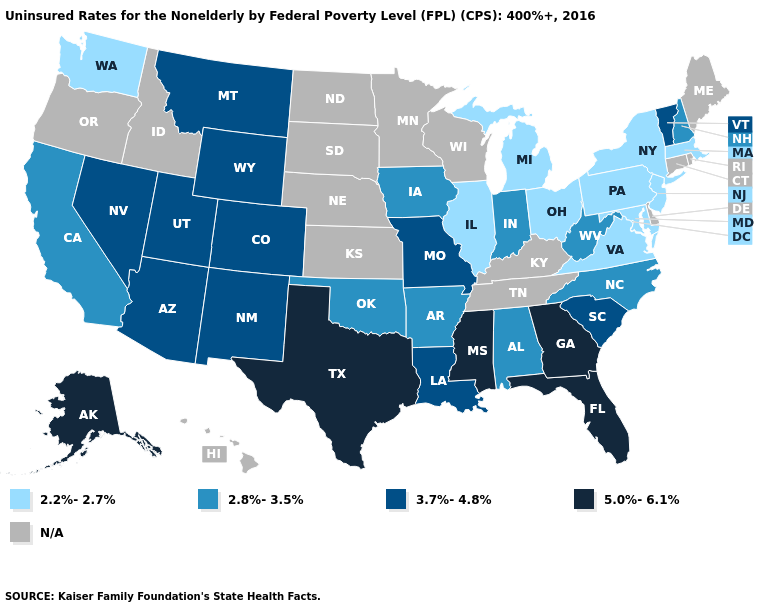Name the states that have a value in the range 3.7%-4.8%?
Concise answer only. Arizona, Colorado, Louisiana, Missouri, Montana, Nevada, New Mexico, South Carolina, Utah, Vermont, Wyoming. Name the states that have a value in the range 2.2%-2.7%?
Answer briefly. Illinois, Maryland, Massachusetts, Michigan, New Jersey, New York, Ohio, Pennsylvania, Virginia, Washington. What is the highest value in states that border Massachusetts?
Write a very short answer. 3.7%-4.8%. What is the value of Connecticut?
Quick response, please. N/A. Does California have the lowest value in the USA?
Give a very brief answer. No. Does Wyoming have the lowest value in the West?
Answer briefly. No. Which states have the highest value in the USA?
Give a very brief answer. Alaska, Florida, Georgia, Mississippi, Texas. Name the states that have a value in the range N/A?
Concise answer only. Connecticut, Delaware, Hawaii, Idaho, Kansas, Kentucky, Maine, Minnesota, Nebraska, North Dakota, Oregon, Rhode Island, South Dakota, Tennessee, Wisconsin. Is the legend a continuous bar?
Give a very brief answer. No. Name the states that have a value in the range 3.7%-4.8%?
Be succinct. Arizona, Colorado, Louisiana, Missouri, Montana, Nevada, New Mexico, South Carolina, Utah, Vermont, Wyoming. Name the states that have a value in the range 2.8%-3.5%?
Concise answer only. Alabama, Arkansas, California, Indiana, Iowa, New Hampshire, North Carolina, Oklahoma, West Virginia. Name the states that have a value in the range 2.2%-2.7%?
Answer briefly. Illinois, Maryland, Massachusetts, Michigan, New Jersey, New York, Ohio, Pennsylvania, Virginia, Washington. Does California have the highest value in the West?
Be succinct. No. Does Iowa have the lowest value in the MidWest?
Short answer required. No. What is the lowest value in the South?
Write a very short answer. 2.2%-2.7%. 